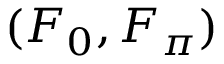Convert formula to latex. <formula><loc_0><loc_0><loc_500><loc_500>( F _ { 0 } , F _ { \pi } )</formula> 